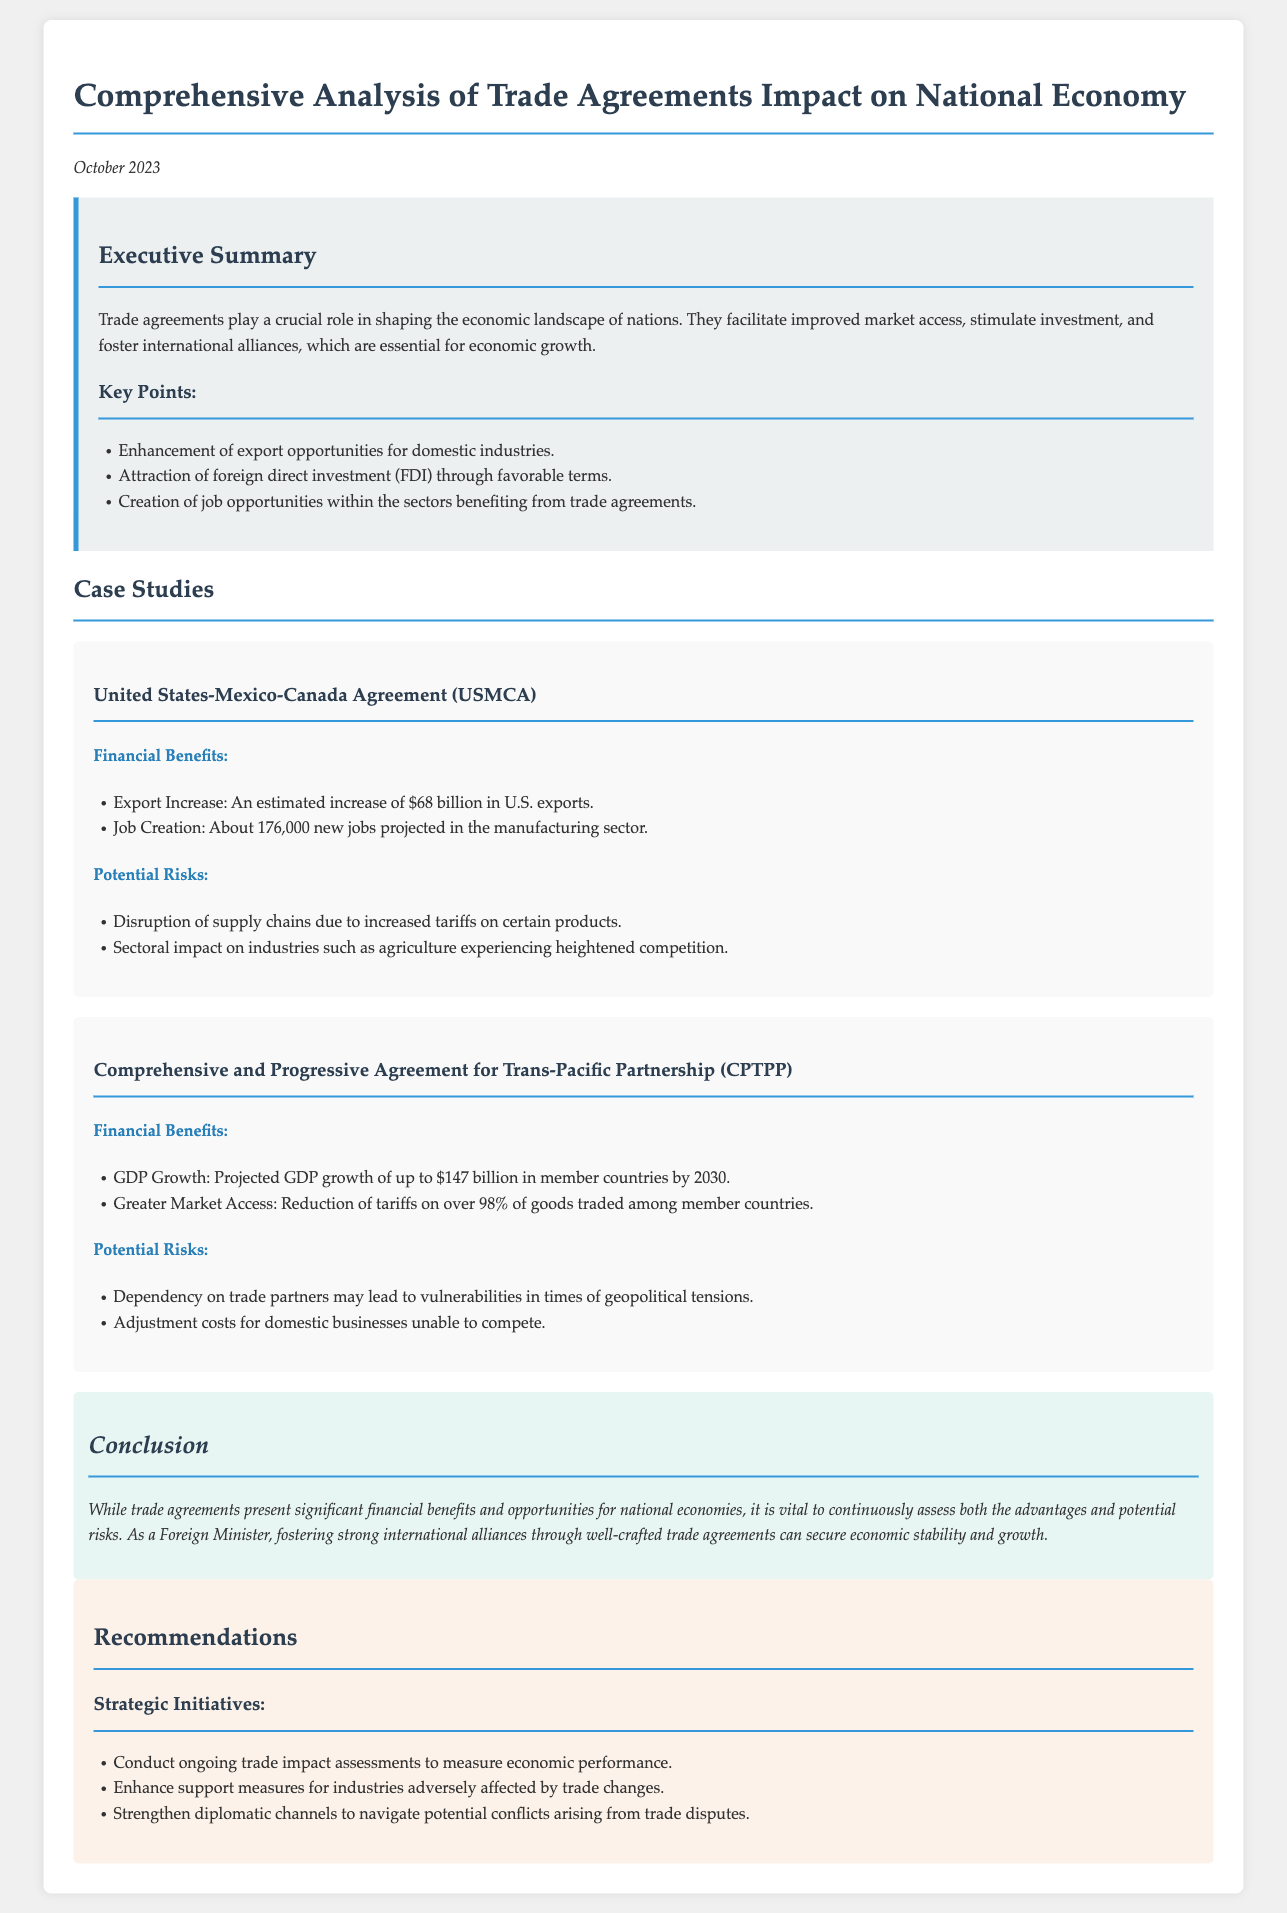what is the trade agreement analyzed in the case study section? The trade agreements analyzed in the case study section are the United States-Mexico-Canada Agreement (USMCA) and the Comprehensive and Progressive Agreement for Trans-Pacific Partnership (CPTPP).
Answer: USMCA and CPTPP how much is the projected GDP growth for CPTPP member countries by 2030? The document states that the projected GDP growth for CPTPP member countries by 2030 is $147 billion.
Answer: $147 billion what is the estimated increase in U.S. exports due to the USMCA? The estimated increase in U.S. exports due to the USMCA is $68 billion.
Answer: $68 billion how many new jobs are projected in the manufacturing sector due to the USMCA? The document indicates that about 176,000 new jobs are projected in the manufacturing sector due to the USMCA.
Answer: 176,000 what are two potential risks mentioned for CPTPP? The document lists potential risks for CPTPP as dependency on trade partners and adjustment costs for domestic businesses unable to compete.
Answer: Dependency on trade partners, adjustment costs what ongoing initiative is recommended for assessing trade impacts? The document recommends conducting ongoing trade impact assessments to measure economic performance.
Answer: Ongoing trade impact assessments what color is used for the recommendations section background? The recommendations section has a background color described in the document as light orange in shade.
Answer: Light orange which key benefit is mentioned for trade agreements in the executive summary? The key benefit mentioned for trade agreements in the executive summary is the enhancement of export opportunities for domestic industries.
Answer: Enhancement of export opportunities how are tariff reductions described in the benefits of CPTPP? The benefits of CPTPP include a reduction of tariffs on over 98% of goods traded among member countries.
Answer: Reduction of tariffs on over 98% of goods 